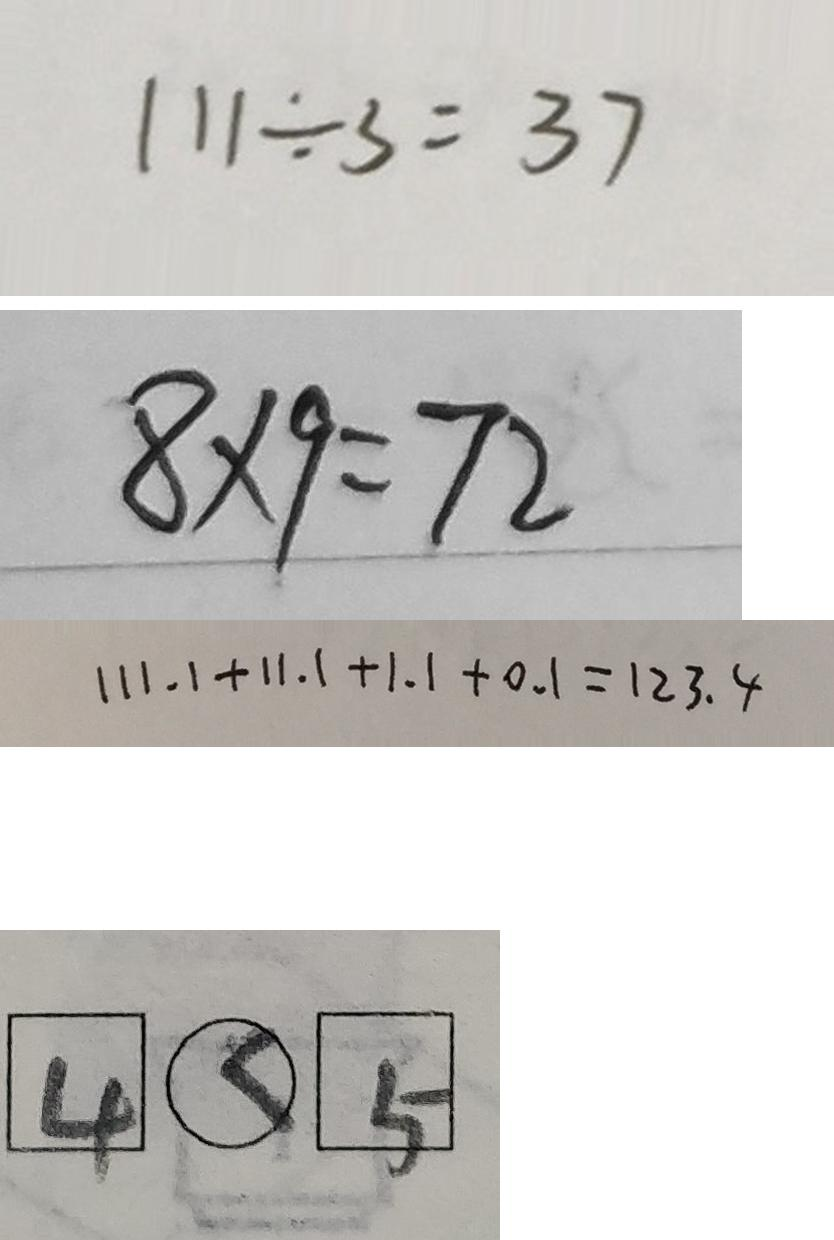Convert formula to latex. <formula><loc_0><loc_0><loc_500><loc_500>1 1 1 \div 3 = 3 7 
 8 \times 9 = 7 2 
 1 1 1 . 1 + 1 1 . 1 + 1 . 1 + 0 . 1 = 1 2 3 . 4 
 \boxed { 4 } \textcircled { < } \boxed { 5 }</formula> 